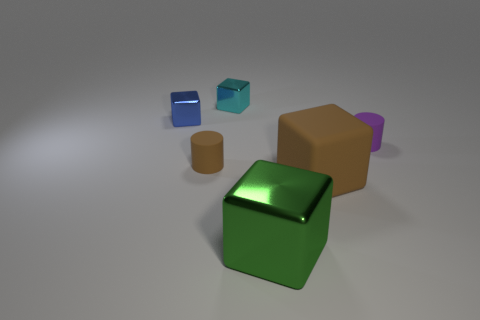Subtract all cyan shiny cubes. How many cubes are left? 3 Add 3 brown matte objects. How many objects exist? 9 Subtract all green cubes. How many cubes are left? 3 Subtract all cylinders. How many objects are left? 4 Add 2 blue shiny objects. How many blue shiny objects exist? 3 Subtract 0 brown spheres. How many objects are left? 6 Subtract all brown cylinders. Subtract all purple cubes. How many cylinders are left? 1 Subtract all big green cylinders. Subtract all tiny blue cubes. How many objects are left? 5 Add 1 metal blocks. How many metal blocks are left? 4 